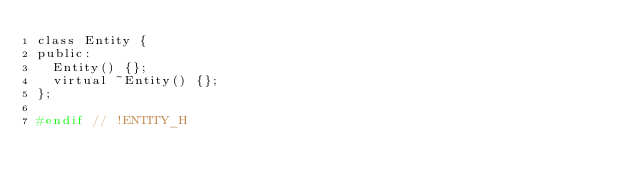<code> <loc_0><loc_0><loc_500><loc_500><_C_>class Entity {
public:
	Entity() {};
	virtual ~Entity() {};
};

#endif // !ENTITY_H
</code> 